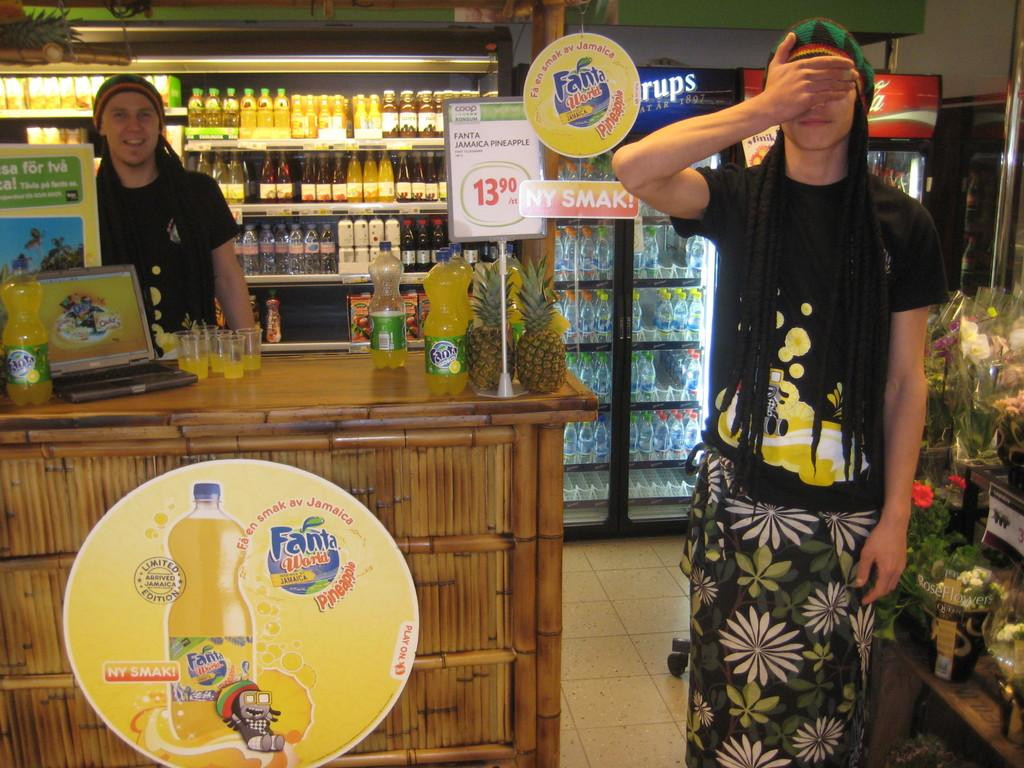Provide a one-sentence caption for the provided image. Two clerks in dreadlocks working at a Hawaiian-themed stand with Fanta featured on the counter. 